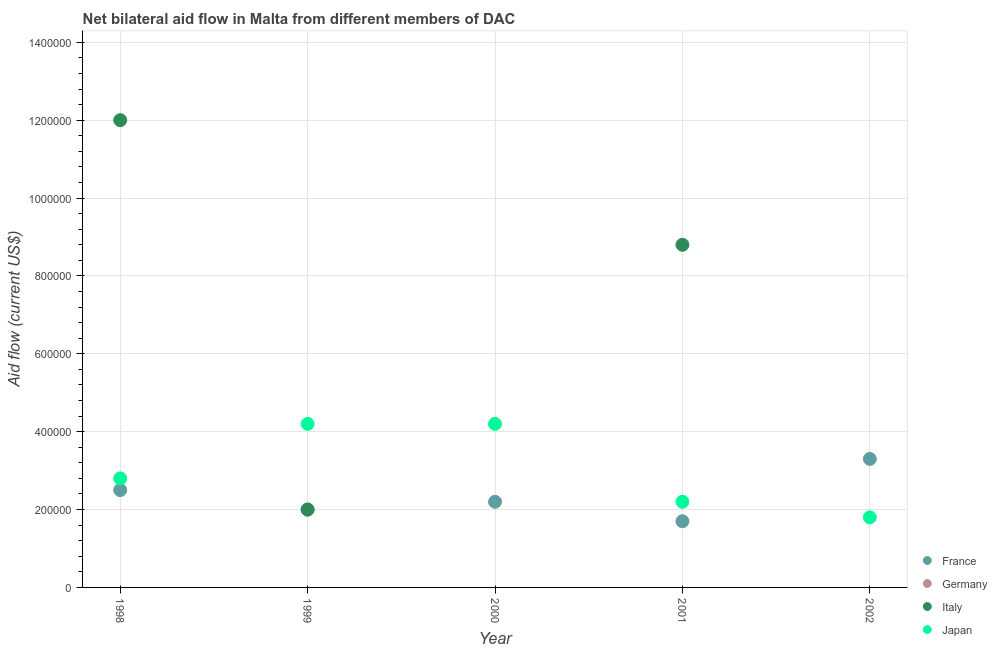Across all years, what is the maximum amount of aid given by italy?
Keep it short and to the point. 1.20e+06. What is the total amount of aid given by japan in the graph?
Your answer should be compact. 1.52e+06. What is the difference between the amount of aid given by france in 1998 and that in 2001?
Provide a short and direct response. 8.00e+04. What is the difference between the amount of aid given by japan in 2002 and the amount of aid given by italy in 1998?
Provide a short and direct response. -1.02e+06. What is the average amount of aid given by japan per year?
Your answer should be compact. 3.04e+05. In the year 1999, what is the difference between the amount of aid given by japan and amount of aid given by italy?
Provide a succinct answer. 2.20e+05. What is the ratio of the amount of aid given by france in 1998 to that in 2001?
Provide a short and direct response. 1.47. Is the amount of aid given by japan in 2000 less than that in 2001?
Your answer should be very brief. No. Is the difference between the amount of aid given by france in 1999 and 2001 greater than the difference between the amount of aid given by japan in 1999 and 2001?
Make the answer very short. No. What is the difference between the highest and the lowest amount of aid given by italy?
Ensure brevity in your answer.  1.20e+06. Is it the case that in every year, the sum of the amount of aid given by italy and amount of aid given by japan is greater than the sum of amount of aid given by germany and amount of aid given by france?
Your answer should be compact. No. Is the amount of aid given by germany strictly less than the amount of aid given by italy over the years?
Your answer should be compact. No. Are the values on the major ticks of Y-axis written in scientific E-notation?
Offer a terse response. No. Does the graph contain any zero values?
Your answer should be very brief. Yes. Where does the legend appear in the graph?
Give a very brief answer. Bottom right. How are the legend labels stacked?
Offer a terse response. Vertical. What is the title of the graph?
Offer a terse response. Net bilateral aid flow in Malta from different members of DAC. What is the label or title of the Y-axis?
Offer a terse response. Aid flow (current US$). What is the Aid flow (current US$) in Germany in 1998?
Offer a terse response. 0. What is the Aid flow (current US$) in Italy in 1998?
Your answer should be compact. 1.20e+06. What is the Aid flow (current US$) in France in 1999?
Provide a short and direct response. 2.00e+05. What is the Aid flow (current US$) of Italy in 1999?
Provide a succinct answer. 2.00e+05. What is the Aid flow (current US$) of France in 2000?
Your response must be concise. 2.20e+05. What is the Aid flow (current US$) in Germany in 2001?
Offer a very short reply. 0. What is the Aid flow (current US$) of Italy in 2001?
Your answer should be compact. 8.80e+05. Across all years, what is the maximum Aid flow (current US$) in Italy?
Your answer should be compact. 1.20e+06. Across all years, what is the minimum Aid flow (current US$) of France?
Provide a short and direct response. 1.70e+05. Across all years, what is the minimum Aid flow (current US$) of Japan?
Provide a succinct answer. 1.80e+05. What is the total Aid flow (current US$) in France in the graph?
Offer a very short reply. 1.17e+06. What is the total Aid flow (current US$) in Italy in the graph?
Your answer should be very brief. 2.28e+06. What is the total Aid flow (current US$) of Japan in the graph?
Offer a very short reply. 1.52e+06. What is the difference between the Aid flow (current US$) in Italy in 1998 and that in 1999?
Your answer should be very brief. 1.00e+06. What is the difference between the Aid flow (current US$) in Japan in 1998 and that in 2000?
Your response must be concise. -1.40e+05. What is the difference between the Aid flow (current US$) in Italy in 1998 and that in 2001?
Your answer should be compact. 3.20e+05. What is the difference between the Aid flow (current US$) of Japan in 1998 and that in 2002?
Your response must be concise. 1.00e+05. What is the difference between the Aid flow (current US$) of France in 1999 and that in 2001?
Provide a succinct answer. 3.00e+04. What is the difference between the Aid flow (current US$) of Italy in 1999 and that in 2001?
Offer a very short reply. -6.80e+05. What is the difference between the Aid flow (current US$) in Japan in 1999 and that in 2002?
Your response must be concise. 2.40e+05. What is the difference between the Aid flow (current US$) of France in 2000 and that in 2001?
Give a very brief answer. 5.00e+04. What is the difference between the Aid flow (current US$) in France in 2000 and that in 2002?
Make the answer very short. -1.10e+05. What is the difference between the Aid flow (current US$) in France in 2001 and that in 2002?
Make the answer very short. -1.60e+05. What is the difference between the Aid flow (current US$) in Japan in 2001 and that in 2002?
Provide a succinct answer. 4.00e+04. What is the difference between the Aid flow (current US$) of France in 1998 and the Aid flow (current US$) of Japan in 1999?
Keep it short and to the point. -1.70e+05. What is the difference between the Aid flow (current US$) in Italy in 1998 and the Aid flow (current US$) in Japan in 1999?
Your answer should be compact. 7.80e+05. What is the difference between the Aid flow (current US$) of France in 1998 and the Aid flow (current US$) of Japan in 2000?
Offer a terse response. -1.70e+05. What is the difference between the Aid flow (current US$) in Italy in 1998 and the Aid flow (current US$) in Japan in 2000?
Your answer should be compact. 7.80e+05. What is the difference between the Aid flow (current US$) in France in 1998 and the Aid flow (current US$) in Italy in 2001?
Give a very brief answer. -6.30e+05. What is the difference between the Aid flow (current US$) in Italy in 1998 and the Aid flow (current US$) in Japan in 2001?
Provide a short and direct response. 9.80e+05. What is the difference between the Aid flow (current US$) in France in 1998 and the Aid flow (current US$) in Japan in 2002?
Offer a very short reply. 7.00e+04. What is the difference between the Aid flow (current US$) of Italy in 1998 and the Aid flow (current US$) of Japan in 2002?
Give a very brief answer. 1.02e+06. What is the difference between the Aid flow (current US$) of Italy in 1999 and the Aid flow (current US$) of Japan in 2000?
Your answer should be compact. -2.20e+05. What is the difference between the Aid flow (current US$) in France in 1999 and the Aid flow (current US$) in Italy in 2001?
Make the answer very short. -6.80e+05. What is the difference between the Aid flow (current US$) of France in 1999 and the Aid flow (current US$) of Japan in 2002?
Your answer should be compact. 2.00e+04. What is the difference between the Aid flow (current US$) in Italy in 1999 and the Aid flow (current US$) in Japan in 2002?
Make the answer very short. 2.00e+04. What is the difference between the Aid flow (current US$) of France in 2000 and the Aid flow (current US$) of Italy in 2001?
Give a very brief answer. -6.60e+05. What is the difference between the Aid flow (current US$) of France in 2000 and the Aid flow (current US$) of Japan in 2001?
Provide a succinct answer. 0. What is the difference between the Aid flow (current US$) in Italy in 2001 and the Aid flow (current US$) in Japan in 2002?
Keep it short and to the point. 7.00e+05. What is the average Aid flow (current US$) in France per year?
Provide a short and direct response. 2.34e+05. What is the average Aid flow (current US$) in Germany per year?
Your answer should be very brief. 0. What is the average Aid flow (current US$) in Italy per year?
Your answer should be compact. 4.56e+05. What is the average Aid flow (current US$) in Japan per year?
Offer a terse response. 3.04e+05. In the year 1998, what is the difference between the Aid flow (current US$) of France and Aid flow (current US$) of Italy?
Make the answer very short. -9.50e+05. In the year 1998, what is the difference between the Aid flow (current US$) of France and Aid flow (current US$) of Japan?
Make the answer very short. -3.00e+04. In the year 1998, what is the difference between the Aid flow (current US$) of Italy and Aid flow (current US$) of Japan?
Your response must be concise. 9.20e+05. In the year 1999, what is the difference between the Aid flow (current US$) of France and Aid flow (current US$) of Italy?
Offer a very short reply. 0. In the year 1999, what is the difference between the Aid flow (current US$) of Italy and Aid flow (current US$) of Japan?
Your answer should be compact. -2.20e+05. In the year 2000, what is the difference between the Aid flow (current US$) of France and Aid flow (current US$) of Japan?
Your response must be concise. -2.00e+05. In the year 2001, what is the difference between the Aid flow (current US$) in France and Aid flow (current US$) in Italy?
Make the answer very short. -7.10e+05. In the year 2001, what is the difference between the Aid flow (current US$) in France and Aid flow (current US$) in Japan?
Ensure brevity in your answer.  -5.00e+04. What is the ratio of the Aid flow (current US$) in France in 1998 to that in 1999?
Provide a short and direct response. 1.25. What is the ratio of the Aid flow (current US$) in Italy in 1998 to that in 1999?
Offer a terse response. 6. What is the ratio of the Aid flow (current US$) of France in 1998 to that in 2000?
Offer a terse response. 1.14. What is the ratio of the Aid flow (current US$) in Japan in 1998 to that in 2000?
Offer a terse response. 0.67. What is the ratio of the Aid flow (current US$) of France in 1998 to that in 2001?
Give a very brief answer. 1.47. What is the ratio of the Aid flow (current US$) in Italy in 1998 to that in 2001?
Make the answer very short. 1.36. What is the ratio of the Aid flow (current US$) of Japan in 1998 to that in 2001?
Your answer should be very brief. 1.27. What is the ratio of the Aid flow (current US$) in France in 1998 to that in 2002?
Your response must be concise. 0.76. What is the ratio of the Aid flow (current US$) of Japan in 1998 to that in 2002?
Ensure brevity in your answer.  1.56. What is the ratio of the Aid flow (current US$) of Japan in 1999 to that in 2000?
Make the answer very short. 1. What is the ratio of the Aid flow (current US$) of France in 1999 to that in 2001?
Ensure brevity in your answer.  1.18. What is the ratio of the Aid flow (current US$) in Italy in 1999 to that in 2001?
Your answer should be compact. 0.23. What is the ratio of the Aid flow (current US$) of Japan in 1999 to that in 2001?
Your response must be concise. 1.91. What is the ratio of the Aid flow (current US$) in France in 1999 to that in 2002?
Ensure brevity in your answer.  0.61. What is the ratio of the Aid flow (current US$) in Japan in 1999 to that in 2002?
Keep it short and to the point. 2.33. What is the ratio of the Aid flow (current US$) in France in 2000 to that in 2001?
Your answer should be very brief. 1.29. What is the ratio of the Aid flow (current US$) of Japan in 2000 to that in 2001?
Provide a succinct answer. 1.91. What is the ratio of the Aid flow (current US$) of Japan in 2000 to that in 2002?
Offer a terse response. 2.33. What is the ratio of the Aid flow (current US$) of France in 2001 to that in 2002?
Your answer should be very brief. 0.52. What is the ratio of the Aid flow (current US$) in Japan in 2001 to that in 2002?
Provide a short and direct response. 1.22. What is the difference between the highest and the lowest Aid flow (current US$) of France?
Provide a succinct answer. 1.60e+05. What is the difference between the highest and the lowest Aid flow (current US$) of Italy?
Provide a short and direct response. 1.20e+06. 